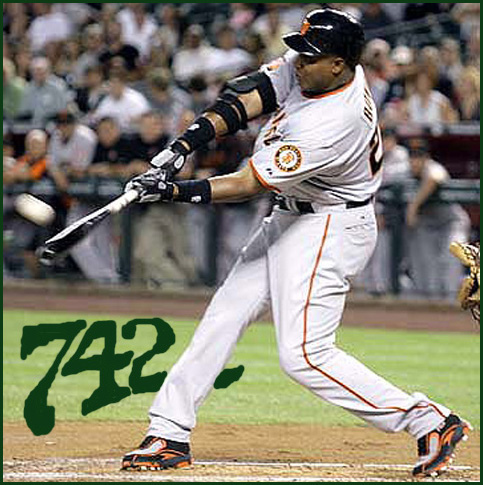<image>What is his name? I don't know his name. It can be 'barry bonds', 'big poppy', '742', 'ryan', or 'brandon'. What is his name? I don't know his name. It could be Barry Bonds, Big Poppy, 742, Ryan, Brandon, or Ruth. 